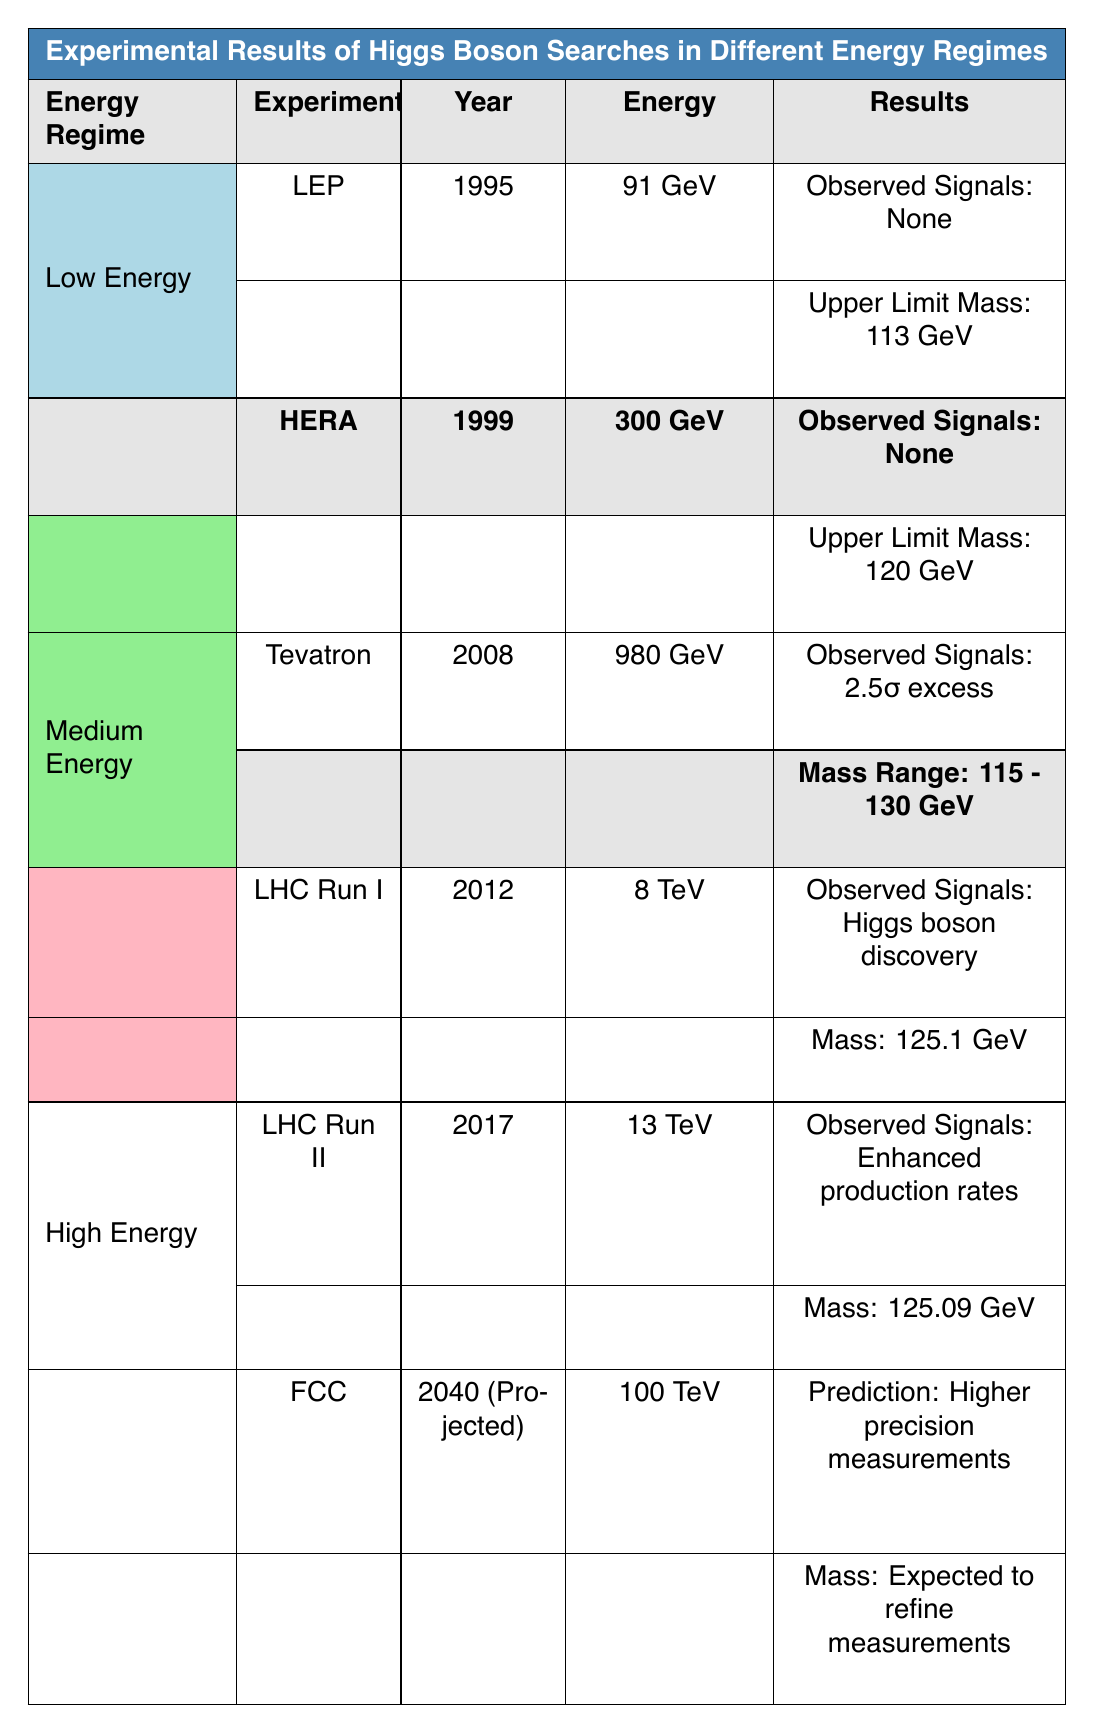What was the upper limit mass for the LEP experiment? The table lists the LEP experiment under the Low Energy regime, and it shows an upper limit mass of 113 GeV.
Answer: 113 GeV Which experiment has the highest recorded energy? The table indicates that the Future Circular Collider (FCC) has a projected energy of 100 TeV, which is the highest energy listed.
Answer: 100 TeV Did any experiment in the Low Energy regime observe any signals? According to the table, both experiments in the Low Energy regime (LEP and HERA) reported observing no signals.
Answer: No What is the mass range reported for the Tevatron experiment? The Tevatron experiment, categorized under Medium Energy, reports a mass range of 115 - 130 GeV according to the table.
Answer: 115 - 130 GeV Between the LHC Run I and LHC Run II experiments, which had a higher energy? The table shows that LHC Run II (2017) had an energy of 13 TeV, while LHC Run I (2012) had an energy of 8 TeV. Therefore, LHC Run II had a higher energy.
Answer: LHC Run II Which Higgs simulation showed evidence for discovery, and in what year? The table highlights that the LHC Run I experiment in 2012 showed evidence for Higgs boson discovery.
Answer: LHC Run I, 2012 If we consider only the Medium Energy experiments, what was the average mass reported? The Tevatron provides a mass range (115 - 130 GeV), which gives an average of (115 + 130) / 2 = 122.5 GeV. LHC Run I has a mass of 125.1 GeV. The average for these two data points is (122.5 + 125.1) / 2 = 123.8 GeV.
Answer: 123.8 GeV What conclusions can we draw about Higgs boson discovery from the table? The Medium and High Energy experiments show significant results: LHC Run I confirmed the Higgs boson discovery, while LHC Run II indicates enhanced production rates. However, Low Energy regimes yielded no signals. Hence, discovery was confirmed primarily at Medium and High Energies.
Answer: Mostly confirmed at Medium and High Energies 